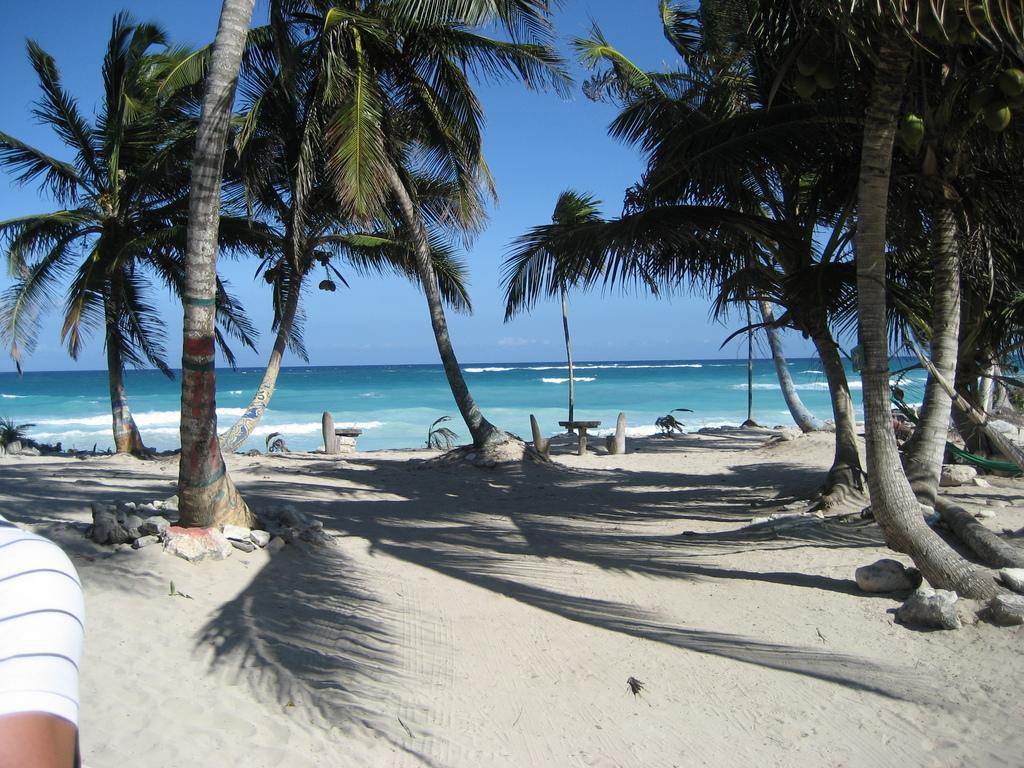In one or two sentences, can you explain what this image depicts? In this image we can see the sea, some coconut trees with coconuts, some plants on the surface, one person shoulder, some cement poles, some sand, one board attached to one tree, one object on the surface and at the top there is the sky. 